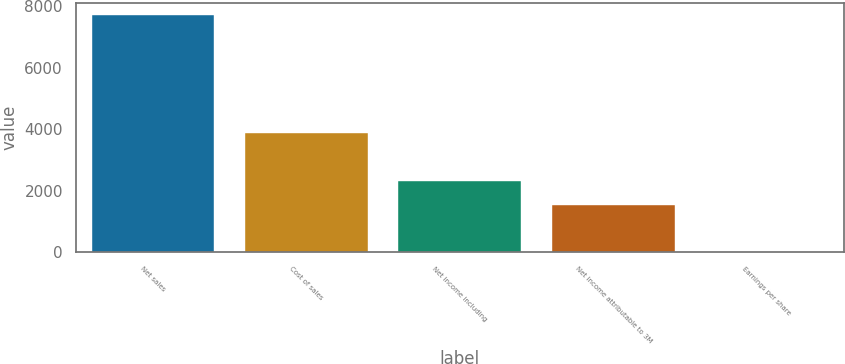Convert chart to OTSL. <chart><loc_0><loc_0><loc_500><loc_500><bar_chart><fcel>Net sales<fcel>Cost of sales<fcel>Net income including<fcel>Net income attributable to 3M<fcel>Earnings per share<nl><fcel>7712<fcel>3877<fcel>2315.03<fcel>1544.03<fcel>2.05<nl></chart> 